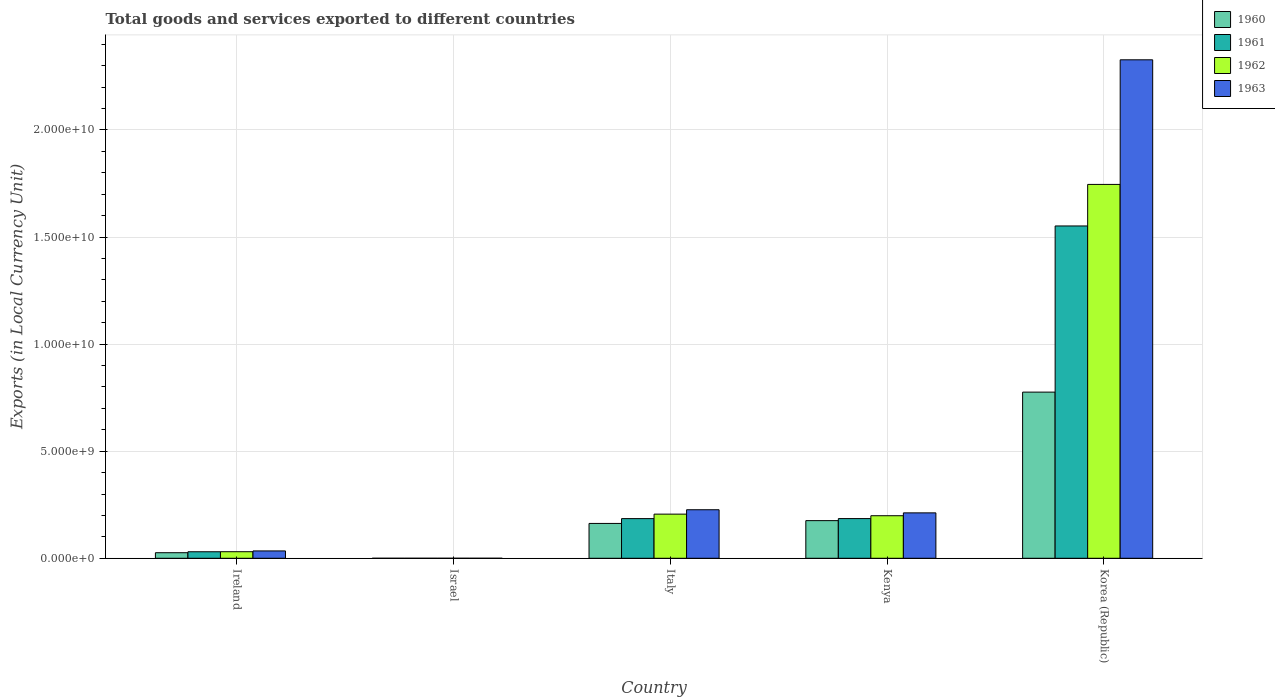How many different coloured bars are there?
Your answer should be compact. 4. Are the number of bars on each tick of the X-axis equal?
Provide a short and direct response. Yes. How many bars are there on the 2nd tick from the left?
Offer a very short reply. 4. What is the label of the 2nd group of bars from the left?
Offer a very short reply. Israel. In how many cases, is the number of bars for a given country not equal to the number of legend labels?
Your answer should be very brief. 0. What is the Amount of goods and services exports in 1963 in Ireland?
Offer a very short reply. 3.43e+08. Across all countries, what is the maximum Amount of goods and services exports in 1962?
Offer a very short reply. 1.75e+1. Across all countries, what is the minimum Amount of goods and services exports in 1961?
Your response must be concise. 7.24e+04. In which country was the Amount of goods and services exports in 1961 minimum?
Your response must be concise. Israel. What is the total Amount of goods and services exports in 1961 in the graph?
Give a very brief answer. 1.95e+1. What is the difference between the Amount of goods and services exports in 1960 in Israel and that in Italy?
Make the answer very short. -1.63e+09. What is the difference between the Amount of goods and services exports in 1960 in Kenya and the Amount of goods and services exports in 1961 in Italy?
Keep it short and to the point. -9.41e+07. What is the average Amount of goods and services exports in 1963 per country?
Keep it short and to the point. 5.60e+09. What is the difference between the Amount of goods and services exports of/in 1960 and Amount of goods and services exports of/in 1961 in Italy?
Give a very brief answer. -2.25e+08. What is the ratio of the Amount of goods and services exports in 1963 in Israel to that in Kenya?
Offer a terse response. 7.895853969152399e-5. Is the Amount of goods and services exports in 1963 in Italy less than that in Korea (Republic)?
Provide a short and direct response. Yes. Is the difference between the Amount of goods and services exports in 1960 in Kenya and Korea (Republic) greater than the difference between the Amount of goods and services exports in 1961 in Kenya and Korea (Republic)?
Offer a terse response. Yes. What is the difference between the highest and the second highest Amount of goods and services exports in 1960?
Make the answer very short. 6.13e+09. What is the difference between the highest and the lowest Amount of goods and services exports in 1960?
Offer a terse response. 7.76e+09. In how many countries, is the Amount of goods and services exports in 1960 greater than the average Amount of goods and services exports in 1960 taken over all countries?
Offer a terse response. 1. Is the sum of the Amount of goods and services exports in 1960 in Ireland and Korea (Republic) greater than the maximum Amount of goods and services exports in 1961 across all countries?
Keep it short and to the point. No. How many countries are there in the graph?
Keep it short and to the point. 5. What is the difference between two consecutive major ticks on the Y-axis?
Offer a terse response. 5.00e+09. Are the values on the major ticks of Y-axis written in scientific E-notation?
Offer a terse response. Yes. Does the graph contain any zero values?
Keep it short and to the point. No. Does the graph contain grids?
Provide a succinct answer. Yes. Where does the legend appear in the graph?
Give a very brief answer. Top right. How are the legend labels stacked?
Provide a short and direct response. Vertical. What is the title of the graph?
Offer a very short reply. Total goods and services exported to different countries. What is the label or title of the Y-axis?
Give a very brief answer. Exports (in Local Currency Unit). What is the Exports (in Local Currency Unit) in 1960 in Ireland?
Offer a terse response. 2.60e+08. What is the Exports (in Local Currency Unit) in 1961 in Ireland?
Offer a very short reply. 3.04e+08. What is the Exports (in Local Currency Unit) in 1962 in Ireland?
Your answer should be compact. 3.07e+08. What is the Exports (in Local Currency Unit) of 1963 in Ireland?
Provide a short and direct response. 3.43e+08. What is the Exports (in Local Currency Unit) of 1960 in Israel?
Provide a short and direct response. 6.19e+04. What is the Exports (in Local Currency Unit) in 1961 in Israel?
Offer a very short reply. 7.24e+04. What is the Exports (in Local Currency Unit) in 1962 in Israel?
Your response must be concise. 1.34e+05. What is the Exports (in Local Currency Unit) in 1963 in Israel?
Your response must be concise. 1.67e+05. What is the Exports (in Local Currency Unit) in 1960 in Italy?
Provide a succinct answer. 1.63e+09. What is the Exports (in Local Currency Unit) of 1961 in Italy?
Give a very brief answer. 1.85e+09. What is the Exports (in Local Currency Unit) in 1962 in Italy?
Keep it short and to the point. 2.06e+09. What is the Exports (in Local Currency Unit) of 1963 in Italy?
Make the answer very short. 2.27e+09. What is the Exports (in Local Currency Unit) of 1960 in Kenya?
Ensure brevity in your answer.  1.76e+09. What is the Exports (in Local Currency Unit) of 1961 in Kenya?
Offer a terse response. 1.85e+09. What is the Exports (in Local Currency Unit) in 1962 in Kenya?
Give a very brief answer. 1.99e+09. What is the Exports (in Local Currency Unit) of 1963 in Kenya?
Offer a very short reply. 2.12e+09. What is the Exports (in Local Currency Unit) of 1960 in Korea (Republic)?
Provide a succinct answer. 7.76e+09. What is the Exports (in Local Currency Unit) in 1961 in Korea (Republic)?
Offer a terse response. 1.55e+1. What is the Exports (in Local Currency Unit) of 1962 in Korea (Republic)?
Your answer should be very brief. 1.75e+1. What is the Exports (in Local Currency Unit) of 1963 in Korea (Republic)?
Provide a succinct answer. 2.33e+1. Across all countries, what is the maximum Exports (in Local Currency Unit) in 1960?
Give a very brief answer. 7.76e+09. Across all countries, what is the maximum Exports (in Local Currency Unit) in 1961?
Your response must be concise. 1.55e+1. Across all countries, what is the maximum Exports (in Local Currency Unit) of 1962?
Provide a short and direct response. 1.75e+1. Across all countries, what is the maximum Exports (in Local Currency Unit) in 1963?
Offer a very short reply. 2.33e+1. Across all countries, what is the minimum Exports (in Local Currency Unit) in 1960?
Offer a terse response. 6.19e+04. Across all countries, what is the minimum Exports (in Local Currency Unit) in 1961?
Your answer should be very brief. 7.24e+04. Across all countries, what is the minimum Exports (in Local Currency Unit) in 1962?
Provide a short and direct response. 1.34e+05. Across all countries, what is the minimum Exports (in Local Currency Unit) in 1963?
Provide a succinct answer. 1.67e+05. What is the total Exports (in Local Currency Unit) in 1960 in the graph?
Offer a terse response. 1.14e+1. What is the total Exports (in Local Currency Unit) in 1961 in the graph?
Your answer should be compact. 1.95e+1. What is the total Exports (in Local Currency Unit) of 1962 in the graph?
Your answer should be very brief. 2.18e+1. What is the total Exports (in Local Currency Unit) of 1963 in the graph?
Provide a succinct answer. 2.80e+1. What is the difference between the Exports (in Local Currency Unit) in 1960 in Ireland and that in Israel?
Make the answer very short. 2.60e+08. What is the difference between the Exports (in Local Currency Unit) in 1961 in Ireland and that in Israel?
Provide a short and direct response. 3.04e+08. What is the difference between the Exports (in Local Currency Unit) of 1962 in Ireland and that in Israel?
Make the answer very short. 3.06e+08. What is the difference between the Exports (in Local Currency Unit) in 1963 in Ireland and that in Israel?
Make the answer very short. 3.43e+08. What is the difference between the Exports (in Local Currency Unit) of 1960 in Ireland and that in Italy?
Ensure brevity in your answer.  -1.37e+09. What is the difference between the Exports (in Local Currency Unit) in 1961 in Ireland and that in Italy?
Give a very brief answer. -1.55e+09. What is the difference between the Exports (in Local Currency Unit) in 1962 in Ireland and that in Italy?
Provide a short and direct response. -1.75e+09. What is the difference between the Exports (in Local Currency Unit) of 1963 in Ireland and that in Italy?
Your answer should be compact. -1.92e+09. What is the difference between the Exports (in Local Currency Unit) of 1960 in Ireland and that in Kenya?
Offer a very short reply. -1.50e+09. What is the difference between the Exports (in Local Currency Unit) in 1961 in Ireland and that in Kenya?
Your answer should be compact. -1.55e+09. What is the difference between the Exports (in Local Currency Unit) in 1962 in Ireland and that in Kenya?
Your answer should be compact. -1.68e+09. What is the difference between the Exports (in Local Currency Unit) in 1963 in Ireland and that in Kenya?
Your answer should be very brief. -1.78e+09. What is the difference between the Exports (in Local Currency Unit) in 1960 in Ireland and that in Korea (Republic)?
Offer a very short reply. -7.50e+09. What is the difference between the Exports (in Local Currency Unit) of 1961 in Ireland and that in Korea (Republic)?
Provide a succinct answer. -1.52e+1. What is the difference between the Exports (in Local Currency Unit) of 1962 in Ireland and that in Korea (Republic)?
Your response must be concise. -1.72e+1. What is the difference between the Exports (in Local Currency Unit) in 1963 in Ireland and that in Korea (Republic)?
Your answer should be very brief. -2.29e+1. What is the difference between the Exports (in Local Currency Unit) of 1960 in Israel and that in Italy?
Provide a succinct answer. -1.63e+09. What is the difference between the Exports (in Local Currency Unit) of 1961 in Israel and that in Italy?
Your answer should be compact. -1.85e+09. What is the difference between the Exports (in Local Currency Unit) of 1962 in Israel and that in Italy?
Offer a terse response. -2.06e+09. What is the difference between the Exports (in Local Currency Unit) of 1963 in Israel and that in Italy?
Your answer should be compact. -2.27e+09. What is the difference between the Exports (in Local Currency Unit) of 1960 in Israel and that in Kenya?
Provide a succinct answer. -1.76e+09. What is the difference between the Exports (in Local Currency Unit) of 1961 in Israel and that in Kenya?
Offer a very short reply. -1.85e+09. What is the difference between the Exports (in Local Currency Unit) in 1962 in Israel and that in Kenya?
Keep it short and to the point. -1.99e+09. What is the difference between the Exports (in Local Currency Unit) in 1963 in Israel and that in Kenya?
Provide a short and direct response. -2.12e+09. What is the difference between the Exports (in Local Currency Unit) of 1960 in Israel and that in Korea (Republic)?
Provide a short and direct response. -7.76e+09. What is the difference between the Exports (in Local Currency Unit) in 1961 in Israel and that in Korea (Republic)?
Your answer should be compact. -1.55e+1. What is the difference between the Exports (in Local Currency Unit) of 1962 in Israel and that in Korea (Republic)?
Your response must be concise. -1.75e+1. What is the difference between the Exports (in Local Currency Unit) in 1963 in Israel and that in Korea (Republic)?
Offer a terse response. -2.33e+1. What is the difference between the Exports (in Local Currency Unit) in 1960 in Italy and that in Kenya?
Give a very brief answer. -1.31e+08. What is the difference between the Exports (in Local Currency Unit) of 1961 in Italy and that in Kenya?
Offer a very short reply. -1.45e+06. What is the difference between the Exports (in Local Currency Unit) of 1962 in Italy and that in Kenya?
Provide a short and direct response. 7.40e+07. What is the difference between the Exports (in Local Currency Unit) of 1963 in Italy and that in Kenya?
Your answer should be very brief. 1.46e+08. What is the difference between the Exports (in Local Currency Unit) in 1960 in Italy and that in Korea (Republic)?
Offer a terse response. -6.13e+09. What is the difference between the Exports (in Local Currency Unit) in 1961 in Italy and that in Korea (Republic)?
Make the answer very short. -1.37e+1. What is the difference between the Exports (in Local Currency Unit) of 1962 in Italy and that in Korea (Republic)?
Your answer should be very brief. -1.54e+1. What is the difference between the Exports (in Local Currency Unit) of 1963 in Italy and that in Korea (Republic)?
Your response must be concise. -2.10e+1. What is the difference between the Exports (in Local Currency Unit) in 1960 in Kenya and that in Korea (Republic)?
Offer a terse response. -6.00e+09. What is the difference between the Exports (in Local Currency Unit) of 1961 in Kenya and that in Korea (Republic)?
Provide a succinct answer. -1.37e+1. What is the difference between the Exports (in Local Currency Unit) in 1962 in Kenya and that in Korea (Republic)?
Offer a very short reply. -1.55e+1. What is the difference between the Exports (in Local Currency Unit) of 1963 in Kenya and that in Korea (Republic)?
Your response must be concise. -2.12e+1. What is the difference between the Exports (in Local Currency Unit) of 1960 in Ireland and the Exports (in Local Currency Unit) of 1961 in Israel?
Offer a very short reply. 2.60e+08. What is the difference between the Exports (in Local Currency Unit) in 1960 in Ireland and the Exports (in Local Currency Unit) in 1962 in Israel?
Your response must be concise. 2.60e+08. What is the difference between the Exports (in Local Currency Unit) of 1960 in Ireland and the Exports (in Local Currency Unit) of 1963 in Israel?
Offer a terse response. 2.60e+08. What is the difference between the Exports (in Local Currency Unit) of 1961 in Ireland and the Exports (in Local Currency Unit) of 1962 in Israel?
Keep it short and to the point. 3.04e+08. What is the difference between the Exports (in Local Currency Unit) in 1961 in Ireland and the Exports (in Local Currency Unit) in 1963 in Israel?
Ensure brevity in your answer.  3.04e+08. What is the difference between the Exports (in Local Currency Unit) in 1962 in Ireland and the Exports (in Local Currency Unit) in 1963 in Israel?
Ensure brevity in your answer.  3.06e+08. What is the difference between the Exports (in Local Currency Unit) in 1960 in Ireland and the Exports (in Local Currency Unit) in 1961 in Italy?
Keep it short and to the point. -1.59e+09. What is the difference between the Exports (in Local Currency Unit) of 1960 in Ireland and the Exports (in Local Currency Unit) of 1962 in Italy?
Provide a succinct answer. -1.80e+09. What is the difference between the Exports (in Local Currency Unit) of 1960 in Ireland and the Exports (in Local Currency Unit) of 1963 in Italy?
Ensure brevity in your answer.  -2.01e+09. What is the difference between the Exports (in Local Currency Unit) of 1961 in Ireland and the Exports (in Local Currency Unit) of 1962 in Italy?
Ensure brevity in your answer.  -1.76e+09. What is the difference between the Exports (in Local Currency Unit) in 1961 in Ireland and the Exports (in Local Currency Unit) in 1963 in Italy?
Make the answer very short. -1.96e+09. What is the difference between the Exports (in Local Currency Unit) in 1962 in Ireland and the Exports (in Local Currency Unit) in 1963 in Italy?
Your answer should be compact. -1.96e+09. What is the difference between the Exports (in Local Currency Unit) of 1960 in Ireland and the Exports (in Local Currency Unit) of 1961 in Kenya?
Ensure brevity in your answer.  -1.59e+09. What is the difference between the Exports (in Local Currency Unit) of 1960 in Ireland and the Exports (in Local Currency Unit) of 1962 in Kenya?
Your answer should be very brief. -1.73e+09. What is the difference between the Exports (in Local Currency Unit) of 1960 in Ireland and the Exports (in Local Currency Unit) of 1963 in Kenya?
Offer a very short reply. -1.86e+09. What is the difference between the Exports (in Local Currency Unit) of 1961 in Ireland and the Exports (in Local Currency Unit) of 1962 in Kenya?
Your response must be concise. -1.68e+09. What is the difference between the Exports (in Local Currency Unit) in 1961 in Ireland and the Exports (in Local Currency Unit) in 1963 in Kenya?
Give a very brief answer. -1.82e+09. What is the difference between the Exports (in Local Currency Unit) of 1962 in Ireland and the Exports (in Local Currency Unit) of 1963 in Kenya?
Ensure brevity in your answer.  -1.81e+09. What is the difference between the Exports (in Local Currency Unit) in 1960 in Ireland and the Exports (in Local Currency Unit) in 1961 in Korea (Republic)?
Provide a short and direct response. -1.53e+1. What is the difference between the Exports (in Local Currency Unit) in 1960 in Ireland and the Exports (in Local Currency Unit) in 1962 in Korea (Republic)?
Your answer should be very brief. -1.72e+1. What is the difference between the Exports (in Local Currency Unit) of 1960 in Ireland and the Exports (in Local Currency Unit) of 1963 in Korea (Republic)?
Keep it short and to the point. -2.30e+1. What is the difference between the Exports (in Local Currency Unit) in 1961 in Ireland and the Exports (in Local Currency Unit) in 1962 in Korea (Republic)?
Keep it short and to the point. -1.72e+1. What is the difference between the Exports (in Local Currency Unit) in 1961 in Ireland and the Exports (in Local Currency Unit) in 1963 in Korea (Republic)?
Provide a succinct answer. -2.30e+1. What is the difference between the Exports (in Local Currency Unit) in 1962 in Ireland and the Exports (in Local Currency Unit) in 1963 in Korea (Republic)?
Offer a very short reply. -2.30e+1. What is the difference between the Exports (in Local Currency Unit) of 1960 in Israel and the Exports (in Local Currency Unit) of 1961 in Italy?
Your response must be concise. -1.85e+09. What is the difference between the Exports (in Local Currency Unit) in 1960 in Israel and the Exports (in Local Currency Unit) in 1962 in Italy?
Offer a very short reply. -2.06e+09. What is the difference between the Exports (in Local Currency Unit) in 1960 in Israel and the Exports (in Local Currency Unit) in 1963 in Italy?
Keep it short and to the point. -2.27e+09. What is the difference between the Exports (in Local Currency Unit) of 1961 in Israel and the Exports (in Local Currency Unit) of 1962 in Italy?
Ensure brevity in your answer.  -2.06e+09. What is the difference between the Exports (in Local Currency Unit) in 1961 in Israel and the Exports (in Local Currency Unit) in 1963 in Italy?
Keep it short and to the point. -2.27e+09. What is the difference between the Exports (in Local Currency Unit) in 1962 in Israel and the Exports (in Local Currency Unit) in 1963 in Italy?
Give a very brief answer. -2.27e+09. What is the difference between the Exports (in Local Currency Unit) in 1960 in Israel and the Exports (in Local Currency Unit) in 1961 in Kenya?
Keep it short and to the point. -1.85e+09. What is the difference between the Exports (in Local Currency Unit) of 1960 in Israel and the Exports (in Local Currency Unit) of 1962 in Kenya?
Your answer should be compact. -1.99e+09. What is the difference between the Exports (in Local Currency Unit) in 1960 in Israel and the Exports (in Local Currency Unit) in 1963 in Kenya?
Provide a succinct answer. -2.12e+09. What is the difference between the Exports (in Local Currency Unit) in 1961 in Israel and the Exports (in Local Currency Unit) in 1962 in Kenya?
Provide a succinct answer. -1.99e+09. What is the difference between the Exports (in Local Currency Unit) in 1961 in Israel and the Exports (in Local Currency Unit) in 1963 in Kenya?
Offer a terse response. -2.12e+09. What is the difference between the Exports (in Local Currency Unit) in 1962 in Israel and the Exports (in Local Currency Unit) in 1963 in Kenya?
Ensure brevity in your answer.  -2.12e+09. What is the difference between the Exports (in Local Currency Unit) of 1960 in Israel and the Exports (in Local Currency Unit) of 1961 in Korea (Republic)?
Offer a very short reply. -1.55e+1. What is the difference between the Exports (in Local Currency Unit) in 1960 in Israel and the Exports (in Local Currency Unit) in 1962 in Korea (Republic)?
Offer a terse response. -1.75e+1. What is the difference between the Exports (in Local Currency Unit) of 1960 in Israel and the Exports (in Local Currency Unit) of 1963 in Korea (Republic)?
Ensure brevity in your answer.  -2.33e+1. What is the difference between the Exports (in Local Currency Unit) in 1961 in Israel and the Exports (in Local Currency Unit) in 1962 in Korea (Republic)?
Provide a succinct answer. -1.75e+1. What is the difference between the Exports (in Local Currency Unit) of 1961 in Israel and the Exports (in Local Currency Unit) of 1963 in Korea (Republic)?
Your answer should be compact. -2.33e+1. What is the difference between the Exports (in Local Currency Unit) of 1962 in Israel and the Exports (in Local Currency Unit) of 1963 in Korea (Republic)?
Provide a short and direct response. -2.33e+1. What is the difference between the Exports (in Local Currency Unit) of 1960 in Italy and the Exports (in Local Currency Unit) of 1961 in Kenya?
Offer a very short reply. -2.27e+08. What is the difference between the Exports (in Local Currency Unit) of 1960 in Italy and the Exports (in Local Currency Unit) of 1962 in Kenya?
Provide a succinct answer. -3.60e+08. What is the difference between the Exports (in Local Currency Unit) of 1960 in Italy and the Exports (in Local Currency Unit) of 1963 in Kenya?
Ensure brevity in your answer.  -4.94e+08. What is the difference between the Exports (in Local Currency Unit) of 1961 in Italy and the Exports (in Local Currency Unit) of 1962 in Kenya?
Provide a short and direct response. -1.35e+08. What is the difference between the Exports (in Local Currency Unit) of 1961 in Italy and the Exports (in Local Currency Unit) of 1963 in Kenya?
Ensure brevity in your answer.  -2.68e+08. What is the difference between the Exports (in Local Currency Unit) of 1962 in Italy and the Exports (in Local Currency Unit) of 1963 in Kenya?
Provide a succinct answer. -5.95e+07. What is the difference between the Exports (in Local Currency Unit) in 1960 in Italy and the Exports (in Local Currency Unit) in 1961 in Korea (Republic)?
Give a very brief answer. -1.39e+1. What is the difference between the Exports (in Local Currency Unit) of 1960 in Italy and the Exports (in Local Currency Unit) of 1962 in Korea (Republic)?
Give a very brief answer. -1.58e+1. What is the difference between the Exports (in Local Currency Unit) of 1960 in Italy and the Exports (in Local Currency Unit) of 1963 in Korea (Republic)?
Ensure brevity in your answer.  -2.16e+1. What is the difference between the Exports (in Local Currency Unit) of 1961 in Italy and the Exports (in Local Currency Unit) of 1962 in Korea (Republic)?
Keep it short and to the point. -1.56e+1. What is the difference between the Exports (in Local Currency Unit) in 1961 in Italy and the Exports (in Local Currency Unit) in 1963 in Korea (Republic)?
Offer a terse response. -2.14e+1. What is the difference between the Exports (in Local Currency Unit) in 1962 in Italy and the Exports (in Local Currency Unit) in 1963 in Korea (Republic)?
Offer a very short reply. -2.12e+1. What is the difference between the Exports (in Local Currency Unit) of 1960 in Kenya and the Exports (in Local Currency Unit) of 1961 in Korea (Republic)?
Offer a very short reply. -1.38e+1. What is the difference between the Exports (in Local Currency Unit) in 1960 in Kenya and the Exports (in Local Currency Unit) in 1962 in Korea (Republic)?
Give a very brief answer. -1.57e+1. What is the difference between the Exports (in Local Currency Unit) of 1960 in Kenya and the Exports (in Local Currency Unit) of 1963 in Korea (Republic)?
Provide a succinct answer. -2.15e+1. What is the difference between the Exports (in Local Currency Unit) of 1961 in Kenya and the Exports (in Local Currency Unit) of 1962 in Korea (Republic)?
Your answer should be very brief. -1.56e+1. What is the difference between the Exports (in Local Currency Unit) of 1961 in Kenya and the Exports (in Local Currency Unit) of 1963 in Korea (Republic)?
Offer a very short reply. -2.14e+1. What is the difference between the Exports (in Local Currency Unit) in 1962 in Kenya and the Exports (in Local Currency Unit) in 1963 in Korea (Republic)?
Your answer should be very brief. -2.13e+1. What is the average Exports (in Local Currency Unit) in 1960 per country?
Your answer should be compact. 2.28e+09. What is the average Exports (in Local Currency Unit) of 1961 per country?
Ensure brevity in your answer.  3.91e+09. What is the average Exports (in Local Currency Unit) of 1962 per country?
Give a very brief answer. 4.36e+09. What is the average Exports (in Local Currency Unit) of 1963 per country?
Your answer should be compact. 5.60e+09. What is the difference between the Exports (in Local Currency Unit) in 1960 and Exports (in Local Currency Unit) in 1961 in Ireland?
Provide a succinct answer. -4.43e+07. What is the difference between the Exports (in Local Currency Unit) in 1960 and Exports (in Local Currency Unit) in 1962 in Ireland?
Ensure brevity in your answer.  -4.69e+07. What is the difference between the Exports (in Local Currency Unit) of 1960 and Exports (in Local Currency Unit) of 1963 in Ireland?
Offer a very short reply. -8.33e+07. What is the difference between the Exports (in Local Currency Unit) in 1961 and Exports (in Local Currency Unit) in 1962 in Ireland?
Ensure brevity in your answer.  -2.58e+06. What is the difference between the Exports (in Local Currency Unit) of 1961 and Exports (in Local Currency Unit) of 1963 in Ireland?
Ensure brevity in your answer.  -3.90e+07. What is the difference between the Exports (in Local Currency Unit) of 1962 and Exports (in Local Currency Unit) of 1963 in Ireland?
Make the answer very short. -3.64e+07. What is the difference between the Exports (in Local Currency Unit) in 1960 and Exports (in Local Currency Unit) in 1961 in Israel?
Ensure brevity in your answer.  -1.05e+04. What is the difference between the Exports (in Local Currency Unit) of 1960 and Exports (in Local Currency Unit) of 1962 in Israel?
Offer a very short reply. -7.21e+04. What is the difference between the Exports (in Local Currency Unit) of 1960 and Exports (in Local Currency Unit) of 1963 in Israel?
Provide a short and direct response. -1.06e+05. What is the difference between the Exports (in Local Currency Unit) of 1961 and Exports (in Local Currency Unit) of 1962 in Israel?
Offer a very short reply. -6.16e+04. What is the difference between the Exports (in Local Currency Unit) in 1961 and Exports (in Local Currency Unit) in 1963 in Israel?
Ensure brevity in your answer.  -9.50e+04. What is the difference between the Exports (in Local Currency Unit) of 1962 and Exports (in Local Currency Unit) of 1963 in Israel?
Ensure brevity in your answer.  -3.34e+04. What is the difference between the Exports (in Local Currency Unit) of 1960 and Exports (in Local Currency Unit) of 1961 in Italy?
Provide a short and direct response. -2.25e+08. What is the difference between the Exports (in Local Currency Unit) of 1960 and Exports (in Local Currency Unit) of 1962 in Italy?
Keep it short and to the point. -4.34e+08. What is the difference between the Exports (in Local Currency Unit) of 1960 and Exports (in Local Currency Unit) of 1963 in Italy?
Ensure brevity in your answer.  -6.40e+08. What is the difference between the Exports (in Local Currency Unit) in 1961 and Exports (in Local Currency Unit) in 1962 in Italy?
Provide a succinct answer. -2.09e+08. What is the difference between the Exports (in Local Currency Unit) of 1961 and Exports (in Local Currency Unit) of 1963 in Italy?
Your answer should be very brief. -4.14e+08. What is the difference between the Exports (in Local Currency Unit) in 1962 and Exports (in Local Currency Unit) in 1963 in Italy?
Keep it short and to the point. -2.05e+08. What is the difference between the Exports (in Local Currency Unit) in 1960 and Exports (in Local Currency Unit) in 1961 in Kenya?
Provide a succinct answer. -9.56e+07. What is the difference between the Exports (in Local Currency Unit) of 1960 and Exports (in Local Currency Unit) of 1962 in Kenya?
Ensure brevity in your answer.  -2.29e+08. What is the difference between the Exports (in Local Currency Unit) of 1960 and Exports (in Local Currency Unit) of 1963 in Kenya?
Make the answer very short. -3.63e+08. What is the difference between the Exports (in Local Currency Unit) in 1961 and Exports (in Local Currency Unit) in 1962 in Kenya?
Your answer should be compact. -1.33e+08. What is the difference between the Exports (in Local Currency Unit) of 1961 and Exports (in Local Currency Unit) of 1963 in Kenya?
Keep it short and to the point. -2.67e+08. What is the difference between the Exports (in Local Currency Unit) of 1962 and Exports (in Local Currency Unit) of 1963 in Kenya?
Give a very brief answer. -1.34e+08. What is the difference between the Exports (in Local Currency Unit) of 1960 and Exports (in Local Currency Unit) of 1961 in Korea (Republic)?
Provide a succinct answer. -7.76e+09. What is the difference between the Exports (in Local Currency Unit) in 1960 and Exports (in Local Currency Unit) in 1962 in Korea (Republic)?
Your answer should be compact. -9.70e+09. What is the difference between the Exports (in Local Currency Unit) of 1960 and Exports (in Local Currency Unit) of 1963 in Korea (Republic)?
Your answer should be very brief. -1.55e+1. What is the difference between the Exports (in Local Currency Unit) in 1961 and Exports (in Local Currency Unit) in 1962 in Korea (Republic)?
Offer a very short reply. -1.94e+09. What is the difference between the Exports (in Local Currency Unit) in 1961 and Exports (in Local Currency Unit) in 1963 in Korea (Republic)?
Provide a succinct answer. -7.76e+09. What is the difference between the Exports (in Local Currency Unit) in 1962 and Exports (in Local Currency Unit) in 1963 in Korea (Republic)?
Offer a very short reply. -5.82e+09. What is the ratio of the Exports (in Local Currency Unit) in 1960 in Ireland to that in Israel?
Your answer should be very brief. 4195.01. What is the ratio of the Exports (in Local Currency Unit) in 1961 in Ireland to that in Israel?
Your answer should be very brief. 4198.66. What is the ratio of the Exports (in Local Currency Unit) of 1962 in Ireland to that in Israel?
Your answer should be compact. 2287.81. What is the ratio of the Exports (in Local Currency Unit) of 1963 in Ireland to that in Israel?
Ensure brevity in your answer.  2048.97. What is the ratio of the Exports (in Local Currency Unit) of 1960 in Ireland to that in Italy?
Ensure brevity in your answer.  0.16. What is the ratio of the Exports (in Local Currency Unit) in 1961 in Ireland to that in Italy?
Give a very brief answer. 0.16. What is the ratio of the Exports (in Local Currency Unit) in 1962 in Ireland to that in Italy?
Offer a very short reply. 0.15. What is the ratio of the Exports (in Local Currency Unit) of 1963 in Ireland to that in Italy?
Make the answer very short. 0.15. What is the ratio of the Exports (in Local Currency Unit) in 1960 in Ireland to that in Kenya?
Give a very brief answer. 0.15. What is the ratio of the Exports (in Local Currency Unit) in 1961 in Ireland to that in Kenya?
Offer a very short reply. 0.16. What is the ratio of the Exports (in Local Currency Unit) of 1962 in Ireland to that in Kenya?
Provide a succinct answer. 0.15. What is the ratio of the Exports (in Local Currency Unit) in 1963 in Ireland to that in Kenya?
Offer a very short reply. 0.16. What is the ratio of the Exports (in Local Currency Unit) in 1960 in Ireland to that in Korea (Republic)?
Ensure brevity in your answer.  0.03. What is the ratio of the Exports (in Local Currency Unit) of 1961 in Ireland to that in Korea (Republic)?
Provide a short and direct response. 0.02. What is the ratio of the Exports (in Local Currency Unit) of 1962 in Ireland to that in Korea (Republic)?
Give a very brief answer. 0.02. What is the ratio of the Exports (in Local Currency Unit) of 1963 in Ireland to that in Korea (Republic)?
Your response must be concise. 0.01. What is the ratio of the Exports (in Local Currency Unit) in 1963 in Israel to that in Italy?
Provide a succinct answer. 0. What is the ratio of the Exports (in Local Currency Unit) of 1960 in Israel to that in Korea (Republic)?
Give a very brief answer. 0. What is the ratio of the Exports (in Local Currency Unit) in 1961 in Israel to that in Korea (Republic)?
Offer a terse response. 0. What is the ratio of the Exports (in Local Currency Unit) of 1962 in Israel to that in Korea (Republic)?
Offer a very short reply. 0. What is the ratio of the Exports (in Local Currency Unit) of 1963 in Israel to that in Korea (Republic)?
Offer a terse response. 0. What is the ratio of the Exports (in Local Currency Unit) of 1960 in Italy to that in Kenya?
Make the answer very short. 0.93. What is the ratio of the Exports (in Local Currency Unit) in 1961 in Italy to that in Kenya?
Make the answer very short. 1. What is the ratio of the Exports (in Local Currency Unit) of 1962 in Italy to that in Kenya?
Provide a succinct answer. 1.04. What is the ratio of the Exports (in Local Currency Unit) of 1963 in Italy to that in Kenya?
Make the answer very short. 1.07. What is the ratio of the Exports (in Local Currency Unit) in 1960 in Italy to that in Korea (Republic)?
Offer a very short reply. 0.21. What is the ratio of the Exports (in Local Currency Unit) in 1961 in Italy to that in Korea (Republic)?
Offer a terse response. 0.12. What is the ratio of the Exports (in Local Currency Unit) of 1962 in Italy to that in Korea (Republic)?
Provide a succinct answer. 0.12. What is the ratio of the Exports (in Local Currency Unit) of 1963 in Italy to that in Korea (Republic)?
Give a very brief answer. 0.1. What is the ratio of the Exports (in Local Currency Unit) of 1960 in Kenya to that in Korea (Republic)?
Make the answer very short. 0.23. What is the ratio of the Exports (in Local Currency Unit) in 1961 in Kenya to that in Korea (Republic)?
Provide a succinct answer. 0.12. What is the ratio of the Exports (in Local Currency Unit) in 1962 in Kenya to that in Korea (Republic)?
Your answer should be compact. 0.11. What is the ratio of the Exports (in Local Currency Unit) of 1963 in Kenya to that in Korea (Republic)?
Offer a terse response. 0.09. What is the difference between the highest and the second highest Exports (in Local Currency Unit) of 1960?
Your answer should be very brief. 6.00e+09. What is the difference between the highest and the second highest Exports (in Local Currency Unit) of 1961?
Your answer should be very brief. 1.37e+1. What is the difference between the highest and the second highest Exports (in Local Currency Unit) in 1962?
Make the answer very short. 1.54e+1. What is the difference between the highest and the second highest Exports (in Local Currency Unit) in 1963?
Provide a short and direct response. 2.10e+1. What is the difference between the highest and the lowest Exports (in Local Currency Unit) of 1960?
Your answer should be very brief. 7.76e+09. What is the difference between the highest and the lowest Exports (in Local Currency Unit) in 1961?
Provide a short and direct response. 1.55e+1. What is the difference between the highest and the lowest Exports (in Local Currency Unit) in 1962?
Keep it short and to the point. 1.75e+1. What is the difference between the highest and the lowest Exports (in Local Currency Unit) in 1963?
Your answer should be very brief. 2.33e+1. 